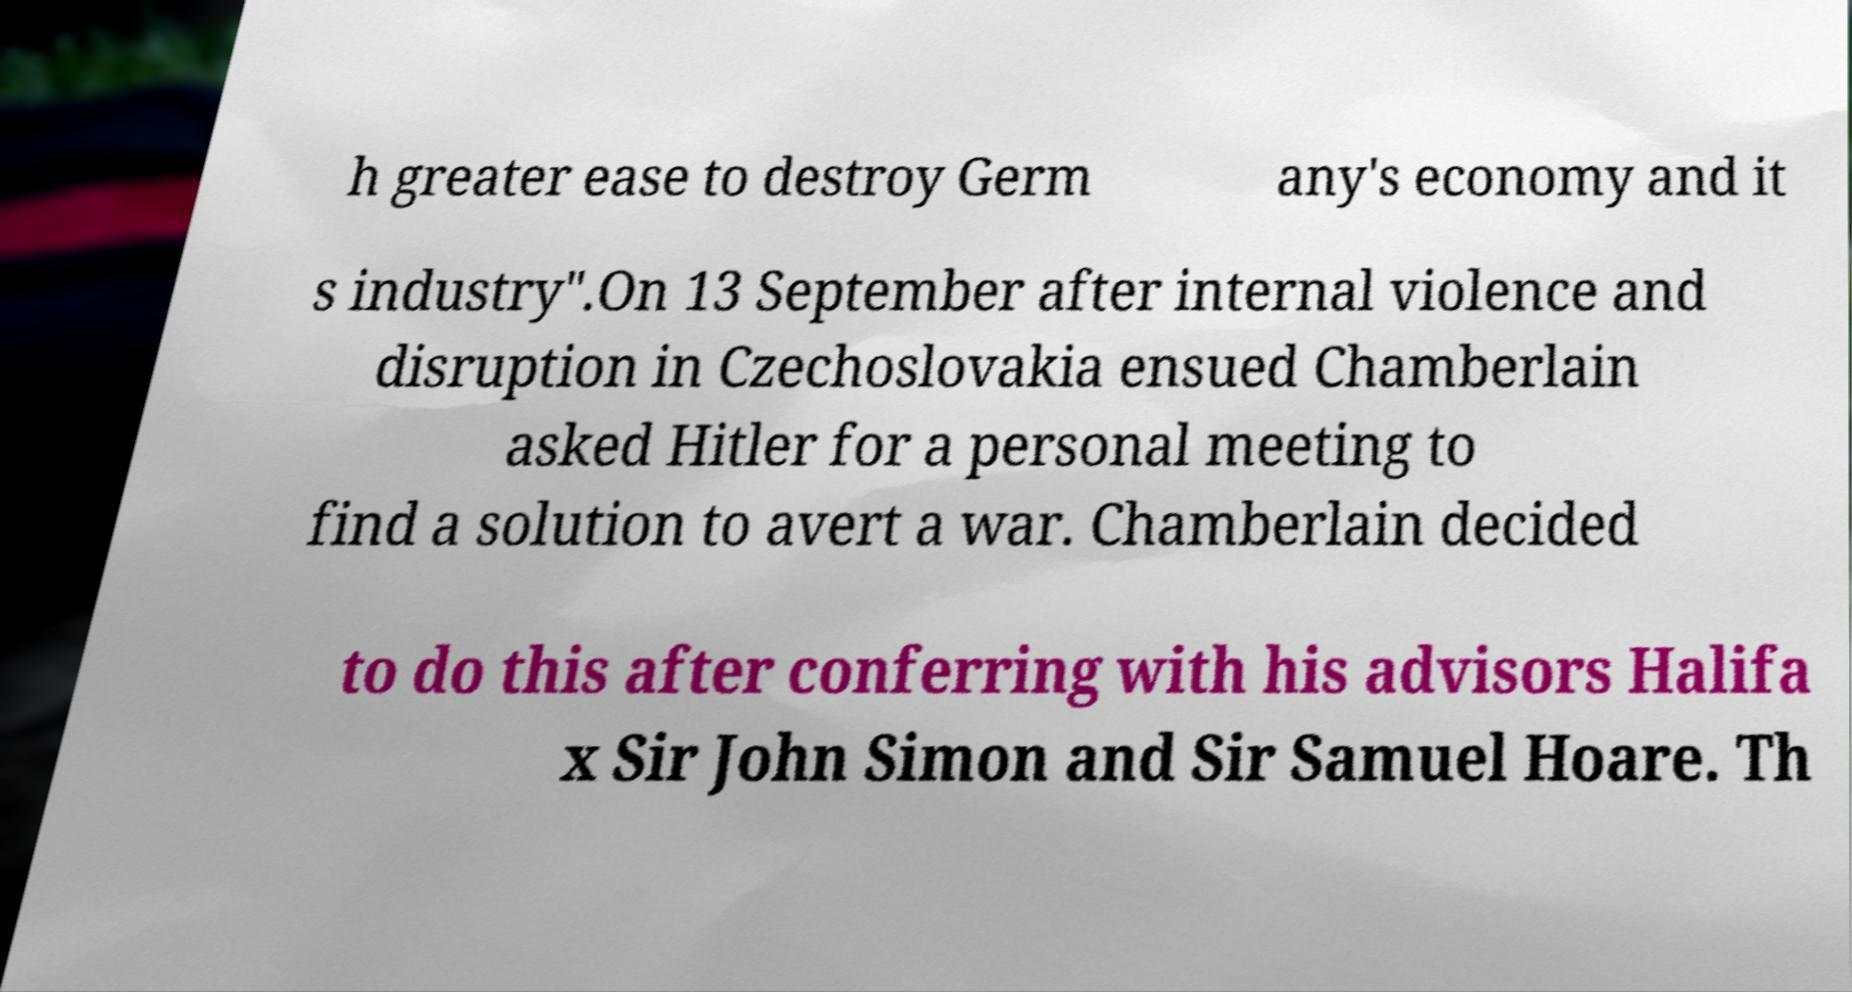Please read and relay the text visible in this image. What does it say? h greater ease to destroy Germ any's economy and it s industry".On 13 September after internal violence and disruption in Czechoslovakia ensued Chamberlain asked Hitler for a personal meeting to find a solution to avert a war. Chamberlain decided to do this after conferring with his advisors Halifa x Sir John Simon and Sir Samuel Hoare. Th 